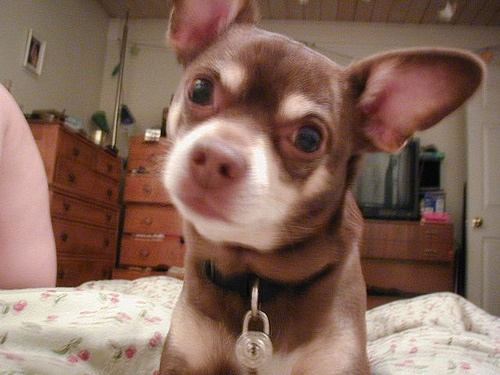Describe the objects in this image and their specific colors. I can see dog in gray, brown, maroon, black, and tan tones, bed in gray, lightgray, and darkgray tones, people in gray, lightpink, salmon, and maroon tones, and tv in gray, black, and maroon tones in this image. 